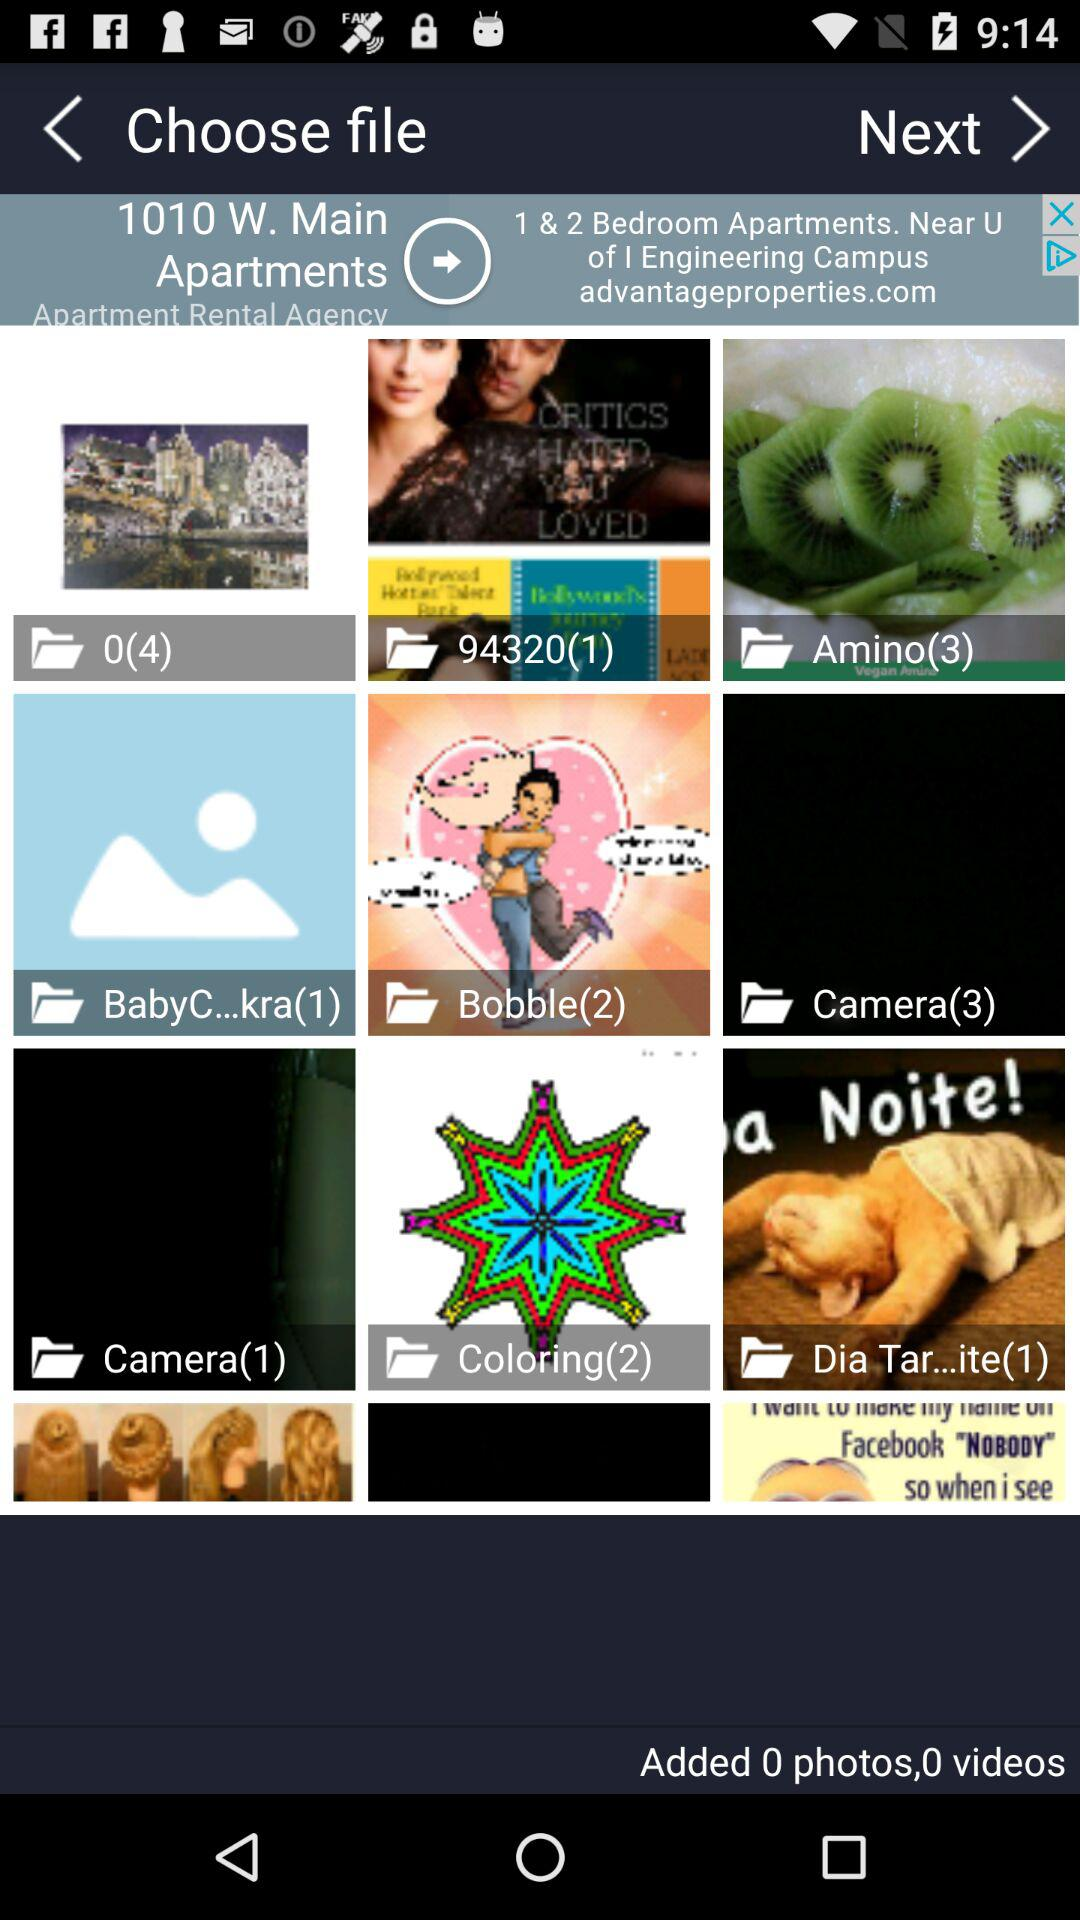What is the number of images in the "Coloring" folder? The number of images in the "Coloring" folder is 2. 